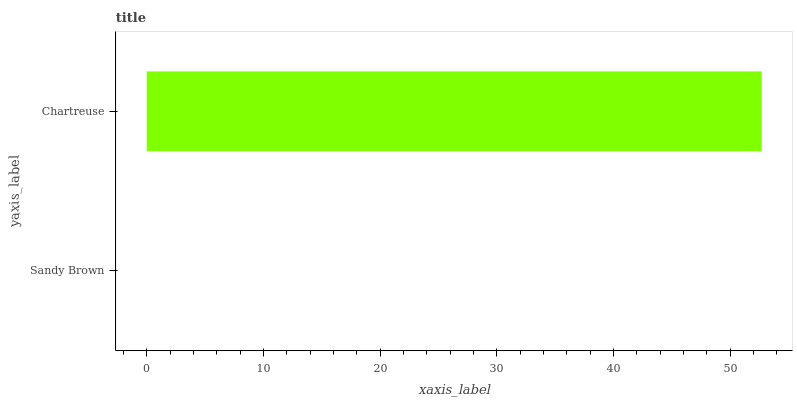Is Sandy Brown the minimum?
Answer yes or no. Yes. Is Chartreuse the maximum?
Answer yes or no. Yes. Is Chartreuse the minimum?
Answer yes or no. No. Is Chartreuse greater than Sandy Brown?
Answer yes or no. Yes. Is Sandy Brown less than Chartreuse?
Answer yes or no. Yes. Is Sandy Brown greater than Chartreuse?
Answer yes or no. No. Is Chartreuse less than Sandy Brown?
Answer yes or no. No. Is Chartreuse the high median?
Answer yes or no. Yes. Is Sandy Brown the low median?
Answer yes or no. Yes. Is Sandy Brown the high median?
Answer yes or no. No. Is Chartreuse the low median?
Answer yes or no. No. 